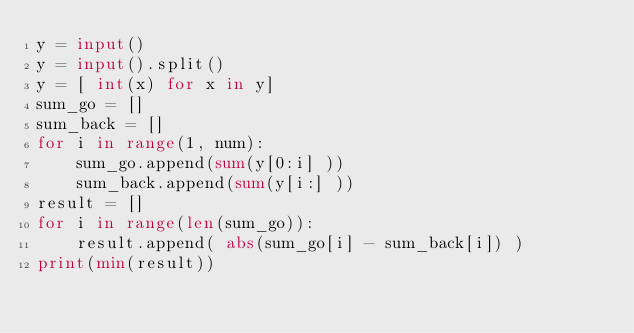Convert code to text. <code><loc_0><loc_0><loc_500><loc_500><_Python_>y = input()
y = input().split()
y = [ int(x) for x in y]
sum_go = []
sum_back = []
for i in range(1, num):
    sum_go.append(sum(y[0:i] ))
    sum_back.append(sum(y[i:] ))
result = []
for i in range(len(sum_go)):
    result.append( abs(sum_go[i] - sum_back[i]) )
print(min(result))</code> 